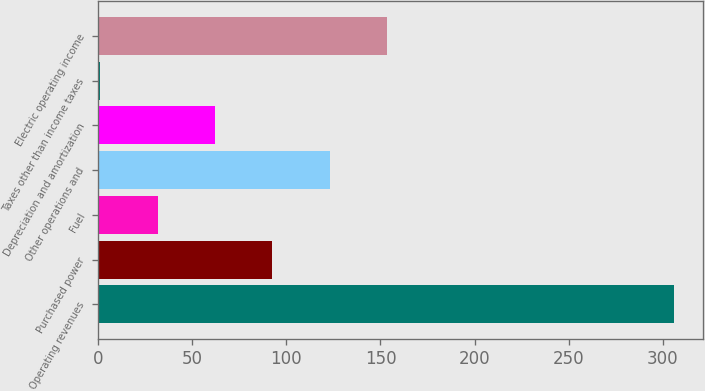<chart> <loc_0><loc_0><loc_500><loc_500><bar_chart><fcel>Operating revenues<fcel>Purchased power<fcel>Fuel<fcel>Other operations and<fcel>Depreciation and amortization<fcel>Taxes other than income taxes<fcel>Electric operating income<nl><fcel>306<fcel>92.5<fcel>31.5<fcel>123<fcel>62<fcel>1<fcel>153.5<nl></chart> 